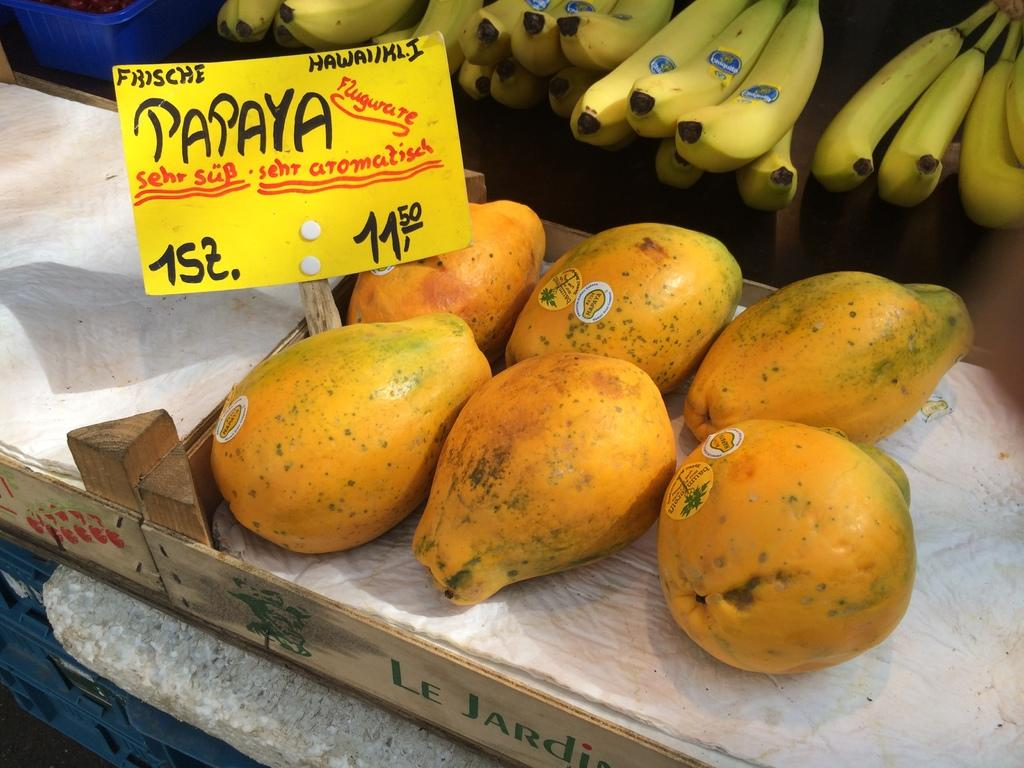What type of food can be seen in the image? There are fruits in the image. What colors are the fruits? The fruits are in orange and yellow colors. What else is in the image that is yellow? There is a yellow color board in the image. On what surface are the fruits placed? The fruits are on a wooden surface. What type of machine is visible in the image? There is no machine present in the image. Can you see an airplane in the image? No, there is no airplane in the image. Is there a chicken in the image? There is no chicken in the image. 